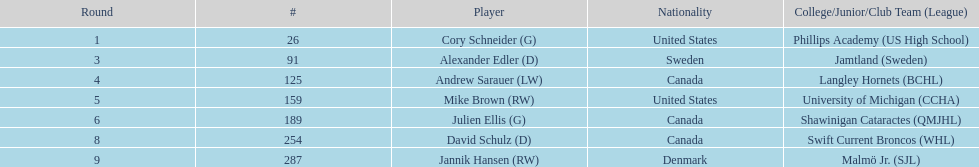What is the count of players who identify as canadian? 3. 